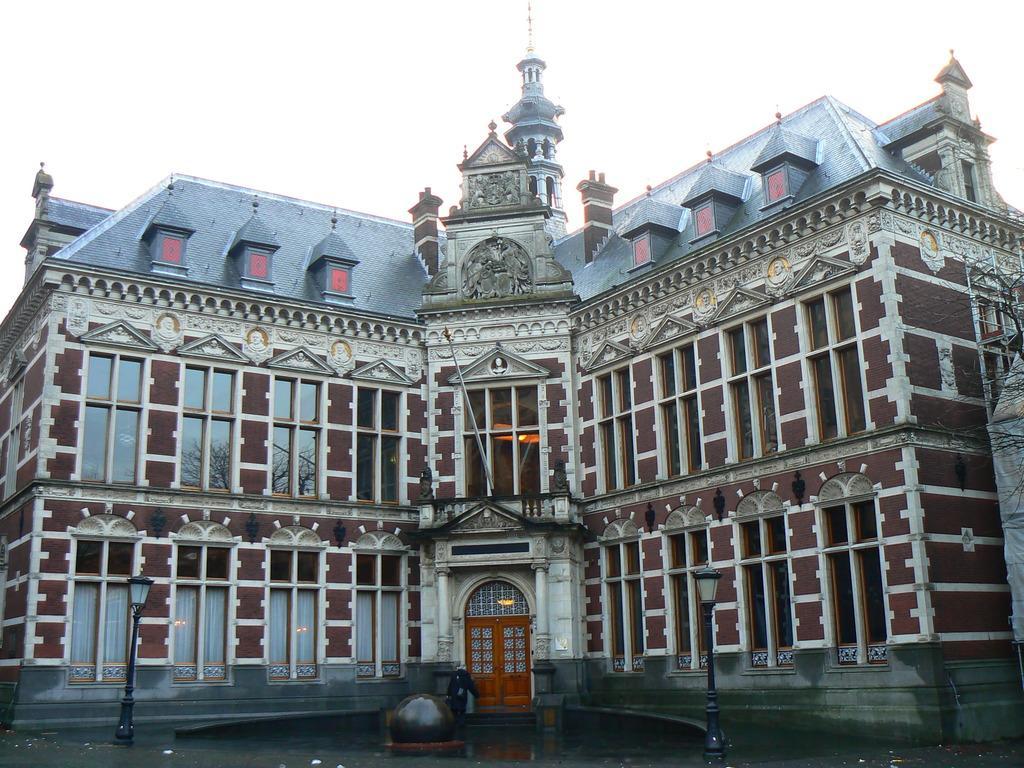Can you describe this image briefly? In this image there is a building. There are sculptures on the walls of the building. In front of the building there are street light poles. At the bottom there is the ground. At the top there is the sky. 